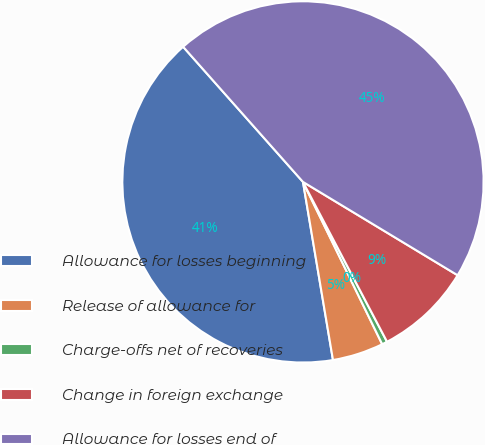Convert chart to OTSL. <chart><loc_0><loc_0><loc_500><loc_500><pie_chart><fcel>Allowance for losses beginning<fcel>Release of allowance for<fcel>Charge-offs net of recoveries<fcel>Change in foreign exchange<fcel>Allowance for losses end of<nl><fcel>41.11%<fcel>4.57%<fcel>0.48%<fcel>8.65%<fcel>45.19%<nl></chart> 